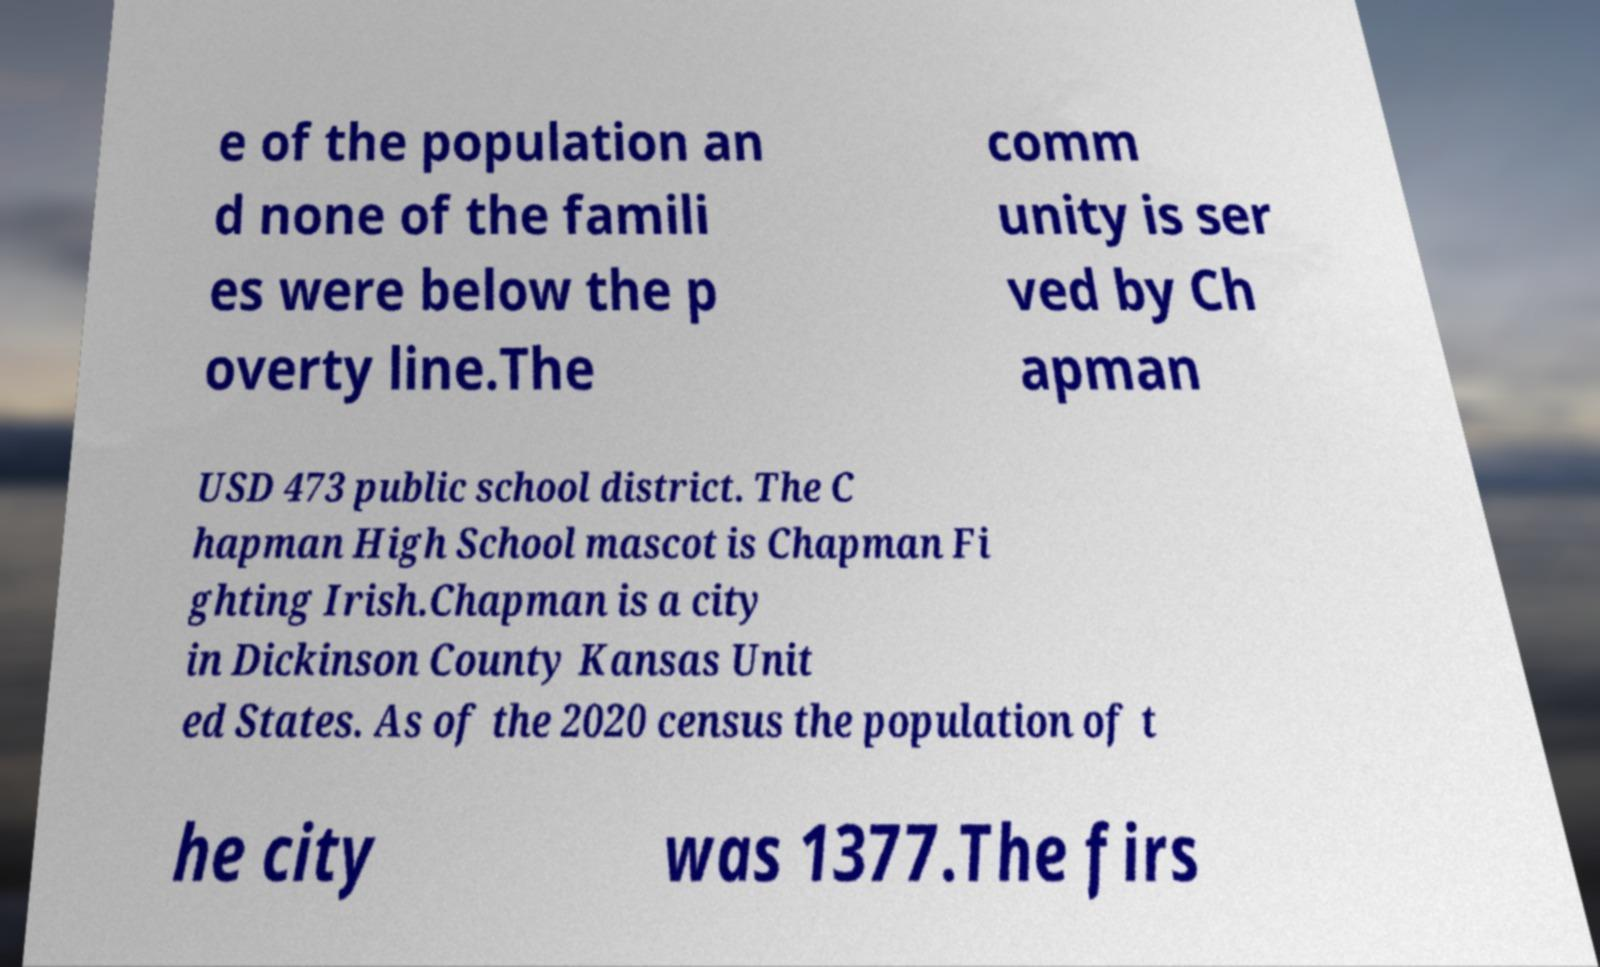Can you accurately transcribe the text from the provided image for me? e of the population an d none of the famili es were below the p overty line.The comm unity is ser ved by Ch apman USD 473 public school district. The C hapman High School mascot is Chapman Fi ghting Irish.Chapman is a city in Dickinson County Kansas Unit ed States. As of the 2020 census the population of t he city was 1377.The firs 